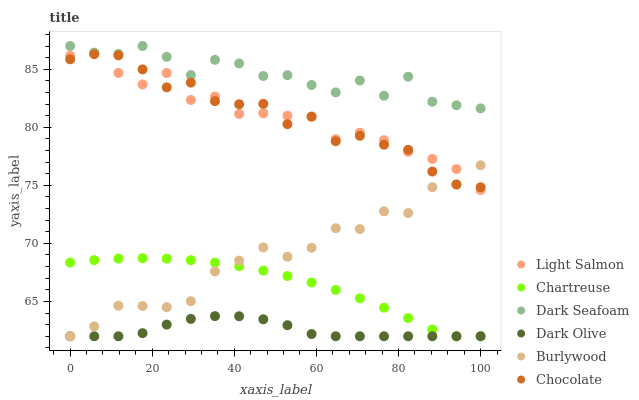Does Dark Olive have the minimum area under the curve?
Answer yes or no. Yes. Does Dark Seafoam have the maximum area under the curve?
Answer yes or no. Yes. Does Burlywood have the minimum area under the curve?
Answer yes or no. No. Does Burlywood have the maximum area under the curve?
Answer yes or no. No. Is Chartreuse the smoothest?
Answer yes or no. Yes. Is Dark Seafoam the roughest?
Answer yes or no. Yes. Is Burlywood the smoothest?
Answer yes or no. No. Is Burlywood the roughest?
Answer yes or no. No. Does Burlywood have the lowest value?
Answer yes or no. Yes. Does Dark Seafoam have the lowest value?
Answer yes or no. No. Does Dark Seafoam have the highest value?
Answer yes or no. Yes. Does Burlywood have the highest value?
Answer yes or no. No. Is Dark Olive less than Light Salmon?
Answer yes or no. Yes. Is Dark Seafoam greater than Burlywood?
Answer yes or no. Yes. Does Burlywood intersect Chocolate?
Answer yes or no. Yes. Is Burlywood less than Chocolate?
Answer yes or no. No. Is Burlywood greater than Chocolate?
Answer yes or no. No. Does Dark Olive intersect Light Salmon?
Answer yes or no. No. 